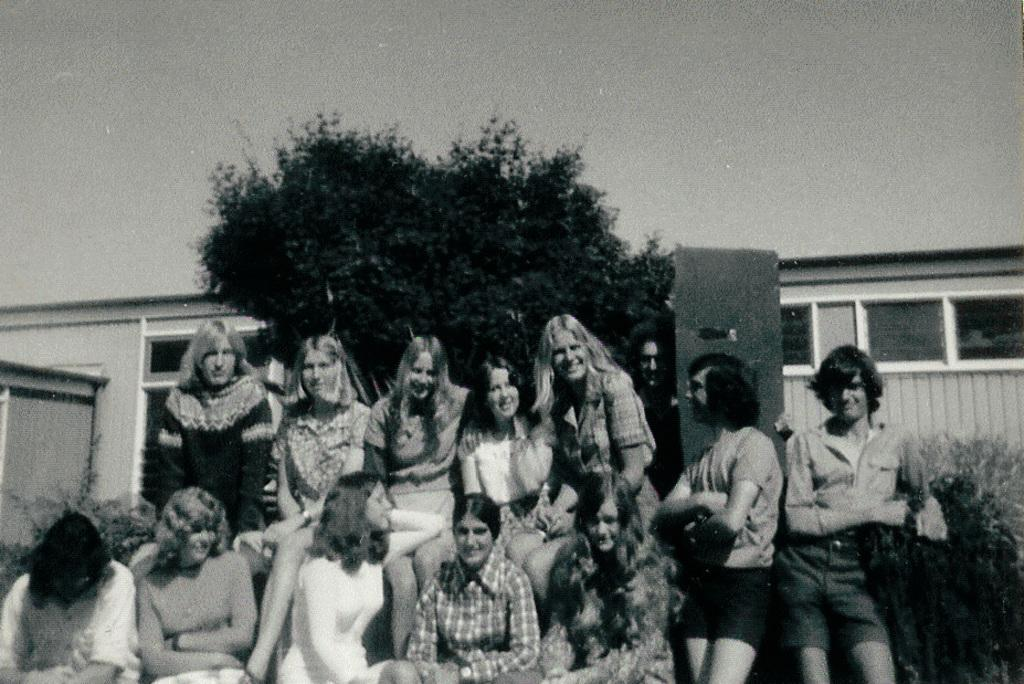What are the women in the image doing? The women in the image are sitting and standing. Can you describe the background of the image? There are trees and a building visible in the background of the image. What is the condition of the sky in the image? The sky is clear in the image. Can you see a volleyball game happening in the image? There is no volleyball game present in the image. Is the ocean visible in the image? The ocean is not visible in the image. Is the sun setting in the image? The sun is not depicted as setting in the image. 